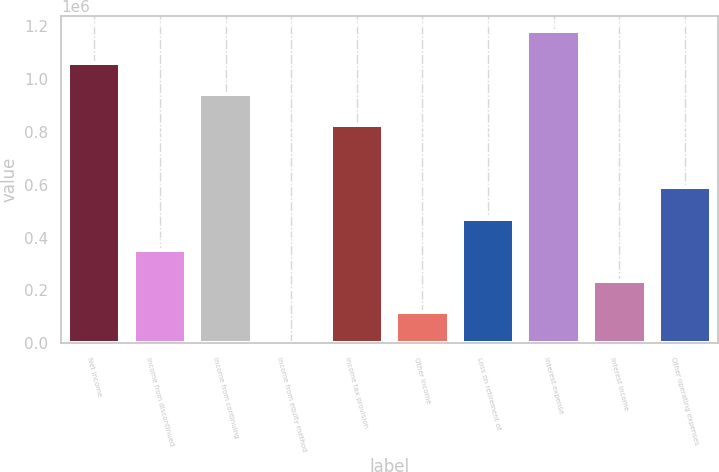Convert chart. <chart><loc_0><loc_0><loc_500><loc_500><bar_chart><fcel>Net income<fcel>Income from discontinued<fcel>Income from continuing<fcel>Income from equity method<fcel>Income tax provision<fcel>Other income<fcel>Loss on retirement of<fcel>Interest expense<fcel>Interest income<fcel>Other operating expenses<nl><fcel>1.06284e+06<fcel>354296<fcel>944745<fcel>26<fcel>826655<fcel>118116<fcel>472386<fcel>1.18092e+06<fcel>236206<fcel>590476<nl></chart> 